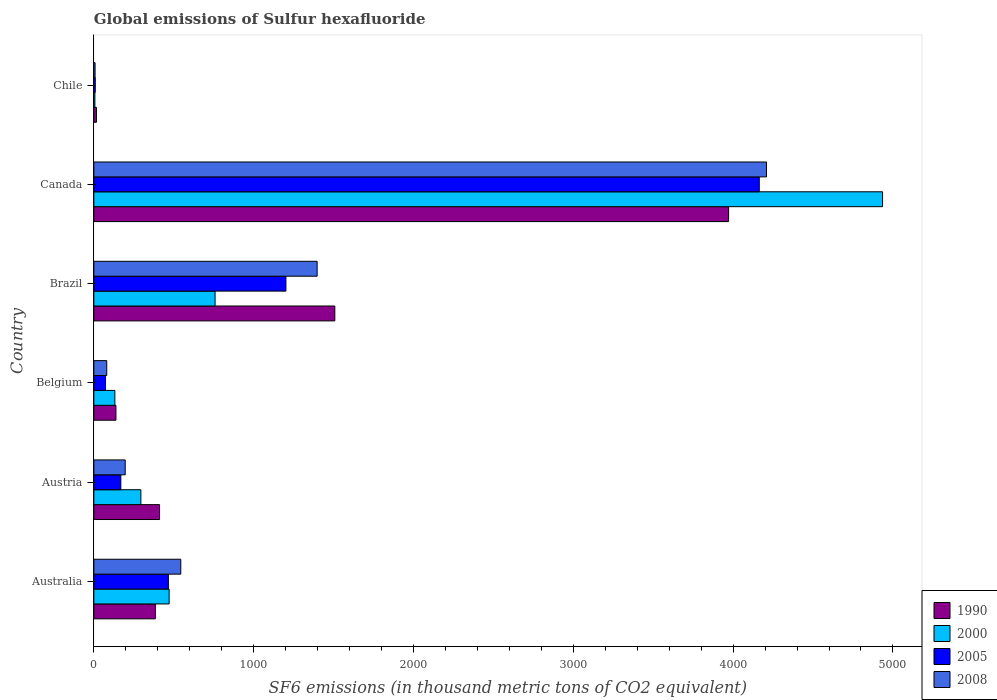How many groups of bars are there?
Your answer should be compact. 6. How many bars are there on the 1st tick from the top?
Your answer should be very brief. 4. How many bars are there on the 2nd tick from the bottom?
Provide a succinct answer. 4. What is the label of the 4th group of bars from the top?
Your answer should be compact. Belgium. In how many cases, is the number of bars for a given country not equal to the number of legend labels?
Offer a terse response. 0. What is the global emissions of Sulfur hexafluoride in 1990 in Brazil?
Your response must be concise. 1507.9. Across all countries, what is the maximum global emissions of Sulfur hexafluoride in 2005?
Your response must be concise. 4163.8. Across all countries, what is the minimum global emissions of Sulfur hexafluoride in 2000?
Your answer should be very brief. 6.7. In which country was the global emissions of Sulfur hexafluoride in 1990 maximum?
Your response must be concise. Canada. What is the total global emissions of Sulfur hexafluoride in 2005 in the graph?
Make the answer very short. 6083.3. What is the difference between the global emissions of Sulfur hexafluoride in 2005 in Australia and that in Austria?
Provide a short and direct response. 297.6. What is the difference between the global emissions of Sulfur hexafluoride in 2005 in Belgium and the global emissions of Sulfur hexafluoride in 1990 in Canada?
Your answer should be compact. -3898.9. What is the average global emissions of Sulfur hexafluoride in 2005 per country?
Offer a terse response. 1013.88. What is the ratio of the global emissions of Sulfur hexafluoride in 2008 in Australia to that in Chile?
Provide a short and direct response. 68.87. What is the difference between the highest and the second highest global emissions of Sulfur hexafluoride in 2005?
Make the answer very short. 2961.8. What is the difference between the highest and the lowest global emissions of Sulfur hexafluoride in 2005?
Your answer should be very brief. 4154.8. In how many countries, is the global emissions of Sulfur hexafluoride in 2000 greater than the average global emissions of Sulfur hexafluoride in 2000 taken over all countries?
Provide a succinct answer. 1. Is it the case that in every country, the sum of the global emissions of Sulfur hexafluoride in 2008 and global emissions of Sulfur hexafluoride in 2000 is greater than the sum of global emissions of Sulfur hexafluoride in 2005 and global emissions of Sulfur hexafluoride in 1990?
Provide a short and direct response. No. Is it the case that in every country, the sum of the global emissions of Sulfur hexafluoride in 2000 and global emissions of Sulfur hexafluoride in 2005 is greater than the global emissions of Sulfur hexafluoride in 2008?
Provide a succinct answer. Yes. How many bars are there?
Provide a short and direct response. 24. Are all the bars in the graph horizontal?
Make the answer very short. Yes. How many countries are there in the graph?
Make the answer very short. 6. Are the values on the major ticks of X-axis written in scientific E-notation?
Give a very brief answer. No. Does the graph contain grids?
Offer a terse response. No. How many legend labels are there?
Provide a short and direct response. 4. What is the title of the graph?
Ensure brevity in your answer.  Global emissions of Sulfur hexafluoride. Does "1960" appear as one of the legend labels in the graph?
Ensure brevity in your answer.  No. What is the label or title of the X-axis?
Your answer should be compact. SF6 emissions (in thousand metric tons of CO2 equivalent). What is the label or title of the Y-axis?
Give a very brief answer. Country. What is the SF6 emissions (in thousand metric tons of CO2 equivalent) in 1990 in Australia?
Offer a very short reply. 385.1. What is the SF6 emissions (in thousand metric tons of CO2 equivalent) of 2000 in Australia?
Make the answer very short. 471.2. What is the SF6 emissions (in thousand metric tons of CO2 equivalent) in 2005 in Australia?
Your answer should be compact. 466.6. What is the SF6 emissions (in thousand metric tons of CO2 equivalent) of 2008 in Australia?
Keep it short and to the point. 544.1. What is the SF6 emissions (in thousand metric tons of CO2 equivalent) in 1990 in Austria?
Provide a succinct answer. 411.2. What is the SF6 emissions (in thousand metric tons of CO2 equivalent) in 2000 in Austria?
Your response must be concise. 294.4. What is the SF6 emissions (in thousand metric tons of CO2 equivalent) in 2005 in Austria?
Your response must be concise. 169. What is the SF6 emissions (in thousand metric tons of CO2 equivalent) in 2008 in Austria?
Ensure brevity in your answer.  196.4. What is the SF6 emissions (in thousand metric tons of CO2 equivalent) of 1990 in Belgium?
Your answer should be very brief. 138.5. What is the SF6 emissions (in thousand metric tons of CO2 equivalent) in 2000 in Belgium?
Keep it short and to the point. 131.7. What is the SF6 emissions (in thousand metric tons of CO2 equivalent) of 2005 in Belgium?
Offer a very short reply. 72.9. What is the SF6 emissions (in thousand metric tons of CO2 equivalent) in 2008 in Belgium?
Your answer should be very brief. 80.9. What is the SF6 emissions (in thousand metric tons of CO2 equivalent) of 1990 in Brazil?
Offer a terse response. 1507.9. What is the SF6 emissions (in thousand metric tons of CO2 equivalent) of 2000 in Brazil?
Your answer should be compact. 758.7. What is the SF6 emissions (in thousand metric tons of CO2 equivalent) of 2005 in Brazil?
Ensure brevity in your answer.  1202. What is the SF6 emissions (in thousand metric tons of CO2 equivalent) of 2008 in Brazil?
Ensure brevity in your answer.  1397.3. What is the SF6 emissions (in thousand metric tons of CO2 equivalent) in 1990 in Canada?
Offer a very short reply. 3971.8. What is the SF6 emissions (in thousand metric tons of CO2 equivalent) in 2000 in Canada?
Make the answer very short. 4935.1. What is the SF6 emissions (in thousand metric tons of CO2 equivalent) in 2005 in Canada?
Your answer should be very brief. 4163.8. What is the SF6 emissions (in thousand metric tons of CO2 equivalent) in 2008 in Canada?
Make the answer very short. 4208.8. What is the SF6 emissions (in thousand metric tons of CO2 equivalent) in 2005 in Chile?
Your response must be concise. 9. What is the SF6 emissions (in thousand metric tons of CO2 equivalent) of 2008 in Chile?
Keep it short and to the point. 7.9. Across all countries, what is the maximum SF6 emissions (in thousand metric tons of CO2 equivalent) of 1990?
Keep it short and to the point. 3971.8. Across all countries, what is the maximum SF6 emissions (in thousand metric tons of CO2 equivalent) of 2000?
Offer a terse response. 4935.1. Across all countries, what is the maximum SF6 emissions (in thousand metric tons of CO2 equivalent) in 2005?
Offer a very short reply. 4163.8. Across all countries, what is the maximum SF6 emissions (in thousand metric tons of CO2 equivalent) in 2008?
Keep it short and to the point. 4208.8. Across all countries, what is the minimum SF6 emissions (in thousand metric tons of CO2 equivalent) in 1990?
Provide a succinct answer. 16.5. Across all countries, what is the minimum SF6 emissions (in thousand metric tons of CO2 equivalent) of 2000?
Your answer should be very brief. 6.7. Across all countries, what is the minimum SF6 emissions (in thousand metric tons of CO2 equivalent) in 2005?
Your response must be concise. 9. What is the total SF6 emissions (in thousand metric tons of CO2 equivalent) in 1990 in the graph?
Ensure brevity in your answer.  6431. What is the total SF6 emissions (in thousand metric tons of CO2 equivalent) in 2000 in the graph?
Your answer should be compact. 6597.8. What is the total SF6 emissions (in thousand metric tons of CO2 equivalent) of 2005 in the graph?
Give a very brief answer. 6083.3. What is the total SF6 emissions (in thousand metric tons of CO2 equivalent) of 2008 in the graph?
Your answer should be compact. 6435.4. What is the difference between the SF6 emissions (in thousand metric tons of CO2 equivalent) in 1990 in Australia and that in Austria?
Make the answer very short. -26.1. What is the difference between the SF6 emissions (in thousand metric tons of CO2 equivalent) in 2000 in Australia and that in Austria?
Give a very brief answer. 176.8. What is the difference between the SF6 emissions (in thousand metric tons of CO2 equivalent) in 2005 in Australia and that in Austria?
Keep it short and to the point. 297.6. What is the difference between the SF6 emissions (in thousand metric tons of CO2 equivalent) of 2008 in Australia and that in Austria?
Keep it short and to the point. 347.7. What is the difference between the SF6 emissions (in thousand metric tons of CO2 equivalent) of 1990 in Australia and that in Belgium?
Give a very brief answer. 246.6. What is the difference between the SF6 emissions (in thousand metric tons of CO2 equivalent) of 2000 in Australia and that in Belgium?
Keep it short and to the point. 339.5. What is the difference between the SF6 emissions (in thousand metric tons of CO2 equivalent) of 2005 in Australia and that in Belgium?
Offer a terse response. 393.7. What is the difference between the SF6 emissions (in thousand metric tons of CO2 equivalent) of 2008 in Australia and that in Belgium?
Ensure brevity in your answer.  463.2. What is the difference between the SF6 emissions (in thousand metric tons of CO2 equivalent) in 1990 in Australia and that in Brazil?
Your answer should be very brief. -1122.8. What is the difference between the SF6 emissions (in thousand metric tons of CO2 equivalent) in 2000 in Australia and that in Brazil?
Give a very brief answer. -287.5. What is the difference between the SF6 emissions (in thousand metric tons of CO2 equivalent) in 2005 in Australia and that in Brazil?
Give a very brief answer. -735.4. What is the difference between the SF6 emissions (in thousand metric tons of CO2 equivalent) of 2008 in Australia and that in Brazil?
Give a very brief answer. -853.2. What is the difference between the SF6 emissions (in thousand metric tons of CO2 equivalent) in 1990 in Australia and that in Canada?
Your answer should be compact. -3586.7. What is the difference between the SF6 emissions (in thousand metric tons of CO2 equivalent) in 2000 in Australia and that in Canada?
Provide a short and direct response. -4463.9. What is the difference between the SF6 emissions (in thousand metric tons of CO2 equivalent) in 2005 in Australia and that in Canada?
Keep it short and to the point. -3697.2. What is the difference between the SF6 emissions (in thousand metric tons of CO2 equivalent) in 2008 in Australia and that in Canada?
Provide a short and direct response. -3664.7. What is the difference between the SF6 emissions (in thousand metric tons of CO2 equivalent) in 1990 in Australia and that in Chile?
Give a very brief answer. 368.6. What is the difference between the SF6 emissions (in thousand metric tons of CO2 equivalent) in 2000 in Australia and that in Chile?
Provide a succinct answer. 464.5. What is the difference between the SF6 emissions (in thousand metric tons of CO2 equivalent) in 2005 in Australia and that in Chile?
Offer a terse response. 457.6. What is the difference between the SF6 emissions (in thousand metric tons of CO2 equivalent) in 2008 in Australia and that in Chile?
Make the answer very short. 536.2. What is the difference between the SF6 emissions (in thousand metric tons of CO2 equivalent) of 1990 in Austria and that in Belgium?
Offer a very short reply. 272.7. What is the difference between the SF6 emissions (in thousand metric tons of CO2 equivalent) in 2000 in Austria and that in Belgium?
Give a very brief answer. 162.7. What is the difference between the SF6 emissions (in thousand metric tons of CO2 equivalent) of 2005 in Austria and that in Belgium?
Your answer should be compact. 96.1. What is the difference between the SF6 emissions (in thousand metric tons of CO2 equivalent) in 2008 in Austria and that in Belgium?
Keep it short and to the point. 115.5. What is the difference between the SF6 emissions (in thousand metric tons of CO2 equivalent) in 1990 in Austria and that in Brazil?
Make the answer very short. -1096.7. What is the difference between the SF6 emissions (in thousand metric tons of CO2 equivalent) in 2000 in Austria and that in Brazil?
Provide a short and direct response. -464.3. What is the difference between the SF6 emissions (in thousand metric tons of CO2 equivalent) of 2005 in Austria and that in Brazil?
Provide a short and direct response. -1033. What is the difference between the SF6 emissions (in thousand metric tons of CO2 equivalent) of 2008 in Austria and that in Brazil?
Offer a terse response. -1200.9. What is the difference between the SF6 emissions (in thousand metric tons of CO2 equivalent) in 1990 in Austria and that in Canada?
Keep it short and to the point. -3560.6. What is the difference between the SF6 emissions (in thousand metric tons of CO2 equivalent) of 2000 in Austria and that in Canada?
Offer a terse response. -4640.7. What is the difference between the SF6 emissions (in thousand metric tons of CO2 equivalent) in 2005 in Austria and that in Canada?
Your response must be concise. -3994.8. What is the difference between the SF6 emissions (in thousand metric tons of CO2 equivalent) in 2008 in Austria and that in Canada?
Your response must be concise. -4012.4. What is the difference between the SF6 emissions (in thousand metric tons of CO2 equivalent) in 1990 in Austria and that in Chile?
Provide a succinct answer. 394.7. What is the difference between the SF6 emissions (in thousand metric tons of CO2 equivalent) of 2000 in Austria and that in Chile?
Your answer should be very brief. 287.7. What is the difference between the SF6 emissions (in thousand metric tons of CO2 equivalent) in 2005 in Austria and that in Chile?
Provide a short and direct response. 160. What is the difference between the SF6 emissions (in thousand metric tons of CO2 equivalent) of 2008 in Austria and that in Chile?
Your response must be concise. 188.5. What is the difference between the SF6 emissions (in thousand metric tons of CO2 equivalent) in 1990 in Belgium and that in Brazil?
Give a very brief answer. -1369.4. What is the difference between the SF6 emissions (in thousand metric tons of CO2 equivalent) of 2000 in Belgium and that in Brazil?
Ensure brevity in your answer.  -627. What is the difference between the SF6 emissions (in thousand metric tons of CO2 equivalent) of 2005 in Belgium and that in Brazil?
Keep it short and to the point. -1129.1. What is the difference between the SF6 emissions (in thousand metric tons of CO2 equivalent) of 2008 in Belgium and that in Brazil?
Give a very brief answer. -1316.4. What is the difference between the SF6 emissions (in thousand metric tons of CO2 equivalent) of 1990 in Belgium and that in Canada?
Provide a succinct answer. -3833.3. What is the difference between the SF6 emissions (in thousand metric tons of CO2 equivalent) of 2000 in Belgium and that in Canada?
Offer a very short reply. -4803.4. What is the difference between the SF6 emissions (in thousand metric tons of CO2 equivalent) of 2005 in Belgium and that in Canada?
Your response must be concise. -4090.9. What is the difference between the SF6 emissions (in thousand metric tons of CO2 equivalent) of 2008 in Belgium and that in Canada?
Provide a short and direct response. -4127.9. What is the difference between the SF6 emissions (in thousand metric tons of CO2 equivalent) of 1990 in Belgium and that in Chile?
Offer a very short reply. 122. What is the difference between the SF6 emissions (in thousand metric tons of CO2 equivalent) of 2000 in Belgium and that in Chile?
Ensure brevity in your answer.  125. What is the difference between the SF6 emissions (in thousand metric tons of CO2 equivalent) in 2005 in Belgium and that in Chile?
Provide a succinct answer. 63.9. What is the difference between the SF6 emissions (in thousand metric tons of CO2 equivalent) of 2008 in Belgium and that in Chile?
Your response must be concise. 73. What is the difference between the SF6 emissions (in thousand metric tons of CO2 equivalent) in 1990 in Brazil and that in Canada?
Your response must be concise. -2463.9. What is the difference between the SF6 emissions (in thousand metric tons of CO2 equivalent) in 2000 in Brazil and that in Canada?
Offer a very short reply. -4176.4. What is the difference between the SF6 emissions (in thousand metric tons of CO2 equivalent) of 2005 in Brazil and that in Canada?
Your response must be concise. -2961.8. What is the difference between the SF6 emissions (in thousand metric tons of CO2 equivalent) in 2008 in Brazil and that in Canada?
Your response must be concise. -2811.5. What is the difference between the SF6 emissions (in thousand metric tons of CO2 equivalent) of 1990 in Brazil and that in Chile?
Your answer should be compact. 1491.4. What is the difference between the SF6 emissions (in thousand metric tons of CO2 equivalent) of 2000 in Brazil and that in Chile?
Your answer should be very brief. 752. What is the difference between the SF6 emissions (in thousand metric tons of CO2 equivalent) of 2005 in Brazil and that in Chile?
Your answer should be compact. 1193. What is the difference between the SF6 emissions (in thousand metric tons of CO2 equivalent) of 2008 in Brazil and that in Chile?
Ensure brevity in your answer.  1389.4. What is the difference between the SF6 emissions (in thousand metric tons of CO2 equivalent) of 1990 in Canada and that in Chile?
Ensure brevity in your answer.  3955.3. What is the difference between the SF6 emissions (in thousand metric tons of CO2 equivalent) of 2000 in Canada and that in Chile?
Offer a very short reply. 4928.4. What is the difference between the SF6 emissions (in thousand metric tons of CO2 equivalent) of 2005 in Canada and that in Chile?
Your answer should be very brief. 4154.8. What is the difference between the SF6 emissions (in thousand metric tons of CO2 equivalent) in 2008 in Canada and that in Chile?
Your answer should be very brief. 4200.9. What is the difference between the SF6 emissions (in thousand metric tons of CO2 equivalent) of 1990 in Australia and the SF6 emissions (in thousand metric tons of CO2 equivalent) of 2000 in Austria?
Your answer should be compact. 90.7. What is the difference between the SF6 emissions (in thousand metric tons of CO2 equivalent) of 1990 in Australia and the SF6 emissions (in thousand metric tons of CO2 equivalent) of 2005 in Austria?
Offer a terse response. 216.1. What is the difference between the SF6 emissions (in thousand metric tons of CO2 equivalent) in 1990 in Australia and the SF6 emissions (in thousand metric tons of CO2 equivalent) in 2008 in Austria?
Ensure brevity in your answer.  188.7. What is the difference between the SF6 emissions (in thousand metric tons of CO2 equivalent) of 2000 in Australia and the SF6 emissions (in thousand metric tons of CO2 equivalent) of 2005 in Austria?
Ensure brevity in your answer.  302.2. What is the difference between the SF6 emissions (in thousand metric tons of CO2 equivalent) in 2000 in Australia and the SF6 emissions (in thousand metric tons of CO2 equivalent) in 2008 in Austria?
Give a very brief answer. 274.8. What is the difference between the SF6 emissions (in thousand metric tons of CO2 equivalent) in 2005 in Australia and the SF6 emissions (in thousand metric tons of CO2 equivalent) in 2008 in Austria?
Ensure brevity in your answer.  270.2. What is the difference between the SF6 emissions (in thousand metric tons of CO2 equivalent) of 1990 in Australia and the SF6 emissions (in thousand metric tons of CO2 equivalent) of 2000 in Belgium?
Your answer should be compact. 253.4. What is the difference between the SF6 emissions (in thousand metric tons of CO2 equivalent) of 1990 in Australia and the SF6 emissions (in thousand metric tons of CO2 equivalent) of 2005 in Belgium?
Offer a terse response. 312.2. What is the difference between the SF6 emissions (in thousand metric tons of CO2 equivalent) in 1990 in Australia and the SF6 emissions (in thousand metric tons of CO2 equivalent) in 2008 in Belgium?
Keep it short and to the point. 304.2. What is the difference between the SF6 emissions (in thousand metric tons of CO2 equivalent) of 2000 in Australia and the SF6 emissions (in thousand metric tons of CO2 equivalent) of 2005 in Belgium?
Provide a succinct answer. 398.3. What is the difference between the SF6 emissions (in thousand metric tons of CO2 equivalent) in 2000 in Australia and the SF6 emissions (in thousand metric tons of CO2 equivalent) in 2008 in Belgium?
Provide a short and direct response. 390.3. What is the difference between the SF6 emissions (in thousand metric tons of CO2 equivalent) in 2005 in Australia and the SF6 emissions (in thousand metric tons of CO2 equivalent) in 2008 in Belgium?
Make the answer very short. 385.7. What is the difference between the SF6 emissions (in thousand metric tons of CO2 equivalent) in 1990 in Australia and the SF6 emissions (in thousand metric tons of CO2 equivalent) in 2000 in Brazil?
Your answer should be compact. -373.6. What is the difference between the SF6 emissions (in thousand metric tons of CO2 equivalent) in 1990 in Australia and the SF6 emissions (in thousand metric tons of CO2 equivalent) in 2005 in Brazil?
Your answer should be compact. -816.9. What is the difference between the SF6 emissions (in thousand metric tons of CO2 equivalent) in 1990 in Australia and the SF6 emissions (in thousand metric tons of CO2 equivalent) in 2008 in Brazil?
Make the answer very short. -1012.2. What is the difference between the SF6 emissions (in thousand metric tons of CO2 equivalent) in 2000 in Australia and the SF6 emissions (in thousand metric tons of CO2 equivalent) in 2005 in Brazil?
Your response must be concise. -730.8. What is the difference between the SF6 emissions (in thousand metric tons of CO2 equivalent) of 2000 in Australia and the SF6 emissions (in thousand metric tons of CO2 equivalent) of 2008 in Brazil?
Offer a terse response. -926.1. What is the difference between the SF6 emissions (in thousand metric tons of CO2 equivalent) in 2005 in Australia and the SF6 emissions (in thousand metric tons of CO2 equivalent) in 2008 in Brazil?
Provide a succinct answer. -930.7. What is the difference between the SF6 emissions (in thousand metric tons of CO2 equivalent) in 1990 in Australia and the SF6 emissions (in thousand metric tons of CO2 equivalent) in 2000 in Canada?
Your response must be concise. -4550. What is the difference between the SF6 emissions (in thousand metric tons of CO2 equivalent) of 1990 in Australia and the SF6 emissions (in thousand metric tons of CO2 equivalent) of 2005 in Canada?
Offer a terse response. -3778.7. What is the difference between the SF6 emissions (in thousand metric tons of CO2 equivalent) of 1990 in Australia and the SF6 emissions (in thousand metric tons of CO2 equivalent) of 2008 in Canada?
Your answer should be very brief. -3823.7. What is the difference between the SF6 emissions (in thousand metric tons of CO2 equivalent) of 2000 in Australia and the SF6 emissions (in thousand metric tons of CO2 equivalent) of 2005 in Canada?
Provide a short and direct response. -3692.6. What is the difference between the SF6 emissions (in thousand metric tons of CO2 equivalent) of 2000 in Australia and the SF6 emissions (in thousand metric tons of CO2 equivalent) of 2008 in Canada?
Keep it short and to the point. -3737.6. What is the difference between the SF6 emissions (in thousand metric tons of CO2 equivalent) in 2005 in Australia and the SF6 emissions (in thousand metric tons of CO2 equivalent) in 2008 in Canada?
Your response must be concise. -3742.2. What is the difference between the SF6 emissions (in thousand metric tons of CO2 equivalent) in 1990 in Australia and the SF6 emissions (in thousand metric tons of CO2 equivalent) in 2000 in Chile?
Give a very brief answer. 378.4. What is the difference between the SF6 emissions (in thousand metric tons of CO2 equivalent) in 1990 in Australia and the SF6 emissions (in thousand metric tons of CO2 equivalent) in 2005 in Chile?
Offer a terse response. 376.1. What is the difference between the SF6 emissions (in thousand metric tons of CO2 equivalent) of 1990 in Australia and the SF6 emissions (in thousand metric tons of CO2 equivalent) of 2008 in Chile?
Keep it short and to the point. 377.2. What is the difference between the SF6 emissions (in thousand metric tons of CO2 equivalent) of 2000 in Australia and the SF6 emissions (in thousand metric tons of CO2 equivalent) of 2005 in Chile?
Make the answer very short. 462.2. What is the difference between the SF6 emissions (in thousand metric tons of CO2 equivalent) of 2000 in Australia and the SF6 emissions (in thousand metric tons of CO2 equivalent) of 2008 in Chile?
Your answer should be very brief. 463.3. What is the difference between the SF6 emissions (in thousand metric tons of CO2 equivalent) of 2005 in Australia and the SF6 emissions (in thousand metric tons of CO2 equivalent) of 2008 in Chile?
Keep it short and to the point. 458.7. What is the difference between the SF6 emissions (in thousand metric tons of CO2 equivalent) of 1990 in Austria and the SF6 emissions (in thousand metric tons of CO2 equivalent) of 2000 in Belgium?
Your answer should be very brief. 279.5. What is the difference between the SF6 emissions (in thousand metric tons of CO2 equivalent) of 1990 in Austria and the SF6 emissions (in thousand metric tons of CO2 equivalent) of 2005 in Belgium?
Give a very brief answer. 338.3. What is the difference between the SF6 emissions (in thousand metric tons of CO2 equivalent) in 1990 in Austria and the SF6 emissions (in thousand metric tons of CO2 equivalent) in 2008 in Belgium?
Provide a succinct answer. 330.3. What is the difference between the SF6 emissions (in thousand metric tons of CO2 equivalent) of 2000 in Austria and the SF6 emissions (in thousand metric tons of CO2 equivalent) of 2005 in Belgium?
Offer a very short reply. 221.5. What is the difference between the SF6 emissions (in thousand metric tons of CO2 equivalent) in 2000 in Austria and the SF6 emissions (in thousand metric tons of CO2 equivalent) in 2008 in Belgium?
Make the answer very short. 213.5. What is the difference between the SF6 emissions (in thousand metric tons of CO2 equivalent) in 2005 in Austria and the SF6 emissions (in thousand metric tons of CO2 equivalent) in 2008 in Belgium?
Offer a very short reply. 88.1. What is the difference between the SF6 emissions (in thousand metric tons of CO2 equivalent) in 1990 in Austria and the SF6 emissions (in thousand metric tons of CO2 equivalent) in 2000 in Brazil?
Your answer should be very brief. -347.5. What is the difference between the SF6 emissions (in thousand metric tons of CO2 equivalent) of 1990 in Austria and the SF6 emissions (in thousand metric tons of CO2 equivalent) of 2005 in Brazil?
Offer a terse response. -790.8. What is the difference between the SF6 emissions (in thousand metric tons of CO2 equivalent) in 1990 in Austria and the SF6 emissions (in thousand metric tons of CO2 equivalent) in 2008 in Brazil?
Your answer should be very brief. -986.1. What is the difference between the SF6 emissions (in thousand metric tons of CO2 equivalent) of 2000 in Austria and the SF6 emissions (in thousand metric tons of CO2 equivalent) of 2005 in Brazil?
Offer a terse response. -907.6. What is the difference between the SF6 emissions (in thousand metric tons of CO2 equivalent) of 2000 in Austria and the SF6 emissions (in thousand metric tons of CO2 equivalent) of 2008 in Brazil?
Offer a very short reply. -1102.9. What is the difference between the SF6 emissions (in thousand metric tons of CO2 equivalent) in 2005 in Austria and the SF6 emissions (in thousand metric tons of CO2 equivalent) in 2008 in Brazil?
Provide a short and direct response. -1228.3. What is the difference between the SF6 emissions (in thousand metric tons of CO2 equivalent) in 1990 in Austria and the SF6 emissions (in thousand metric tons of CO2 equivalent) in 2000 in Canada?
Provide a short and direct response. -4523.9. What is the difference between the SF6 emissions (in thousand metric tons of CO2 equivalent) of 1990 in Austria and the SF6 emissions (in thousand metric tons of CO2 equivalent) of 2005 in Canada?
Offer a very short reply. -3752.6. What is the difference between the SF6 emissions (in thousand metric tons of CO2 equivalent) of 1990 in Austria and the SF6 emissions (in thousand metric tons of CO2 equivalent) of 2008 in Canada?
Give a very brief answer. -3797.6. What is the difference between the SF6 emissions (in thousand metric tons of CO2 equivalent) of 2000 in Austria and the SF6 emissions (in thousand metric tons of CO2 equivalent) of 2005 in Canada?
Your answer should be compact. -3869.4. What is the difference between the SF6 emissions (in thousand metric tons of CO2 equivalent) in 2000 in Austria and the SF6 emissions (in thousand metric tons of CO2 equivalent) in 2008 in Canada?
Make the answer very short. -3914.4. What is the difference between the SF6 emissions (in thousand metric tons of CO2 equivalent) of 2005 in Austria and the SF6 emissions (in thousand metric tons of CO2 equivalent) of 2008 in Canada?
Keep it short and to the point. -4039.8. What is the difference between the SF6 emissions (in thousand metric tons of CO2 equivalent) in 1990 in Austria and the SF6 emissions (in thousand metric tons of CO2 equivalent) in 2000 in Chile?
Offer a very short reply. 404.5. What is the difference between the SF6 emissions (in thousand metric tons of CO2 equivalent) of 1990 in Austria and the SF6 emissions (in thousand metric tons of CO2 equivalent) of 2005 in Chile?
Offer a terse response. 402.2. What is the difference between the SF6 emissions (in thousand metric tons of CO2 equivalent) in 1990 in Austria and the SF6 emissions (in thousand metric tons of CO2 equivalent) in 2008 in Chile?
Offer a very short reply. 403.3. What is the difference between the SF6 emissions (in thousand metric tons of CO2 equivalent) in 2000 in Austria and the SF6 emissions (in thousand metric tons of CO2 equivalent) in 2005 in Chile?
Your answer should be very brief. 285.4. What is the difference between the SF6 emissions (in thousand metric tons of CO2 equivalent) in 2000 in Austria and the SF6 emissions (in thousand metric tons of CO2 equivalent) in 2008 in Chile?
Your response must be concise. 286.5. What is the difference between the SF6 emissions (in thousand metric tons of CO2 equivalent) of 2005 in Austria and the SF6 emissions (in thousand metric tons of CO2 equivalent) of 2008 in Chile?
Give a very brief answer. 161.1. What is the difference between the SF6 emissions (in thousand metric tons of CO2 equivalent) of 1990 in Belgium and the SF6 emissions (in thousand metric tons of CO2 equivalent) of 2000 in Brazil?
Your answer should be very brief. -620.2. What is the difference between the SF6 emissions (in thousand metric tons of CO2 equivalent) in 1990 in Belgium and the SF6 emissions (in thousand metric tons of CO2 equivalent) in 2005 in Brazil?
Offer a terse response. -1063.5. What is the difference between the SF6 emissions (in thousand metric tons of CO2 equivalent) of 1990 in Belgium and the SF6 emissions (in thousand metric tons of CO2 equivalent) of 2008 in Brazil?
Ensure brevity in your answer.  -1258.8. What is the difference between the SF6 emissions (in thousand metric tons of CO2 equivalent) of 2000 in Belgium and the SF6 emissions (in thousand metric tons of CO2 equivalent) of 2005 in Brazil?
Ensure brevity in your answer.  -1070.3. What is the difference between the SF6 emissions (in thousand metric tons of CO2 equivalent) of 2000 in Belgium and the SF6 emissions (in thousand metric tons of CO2 equivalent) of 2008 in Brazil?
Keep it short and to the point. -1265.6. What is the difference between the SF6 emissions (in thousand metric tons of CO2 equivalent) of 2005 in Belgium and the SF6 emissions (in thousand metric tons of CO2 equivalent) of 2008 in Brazil?
Give a very brief answer. -1324.4. What is the difference between the SF6 emissions (in thousand metric tons of CO2 equivalent) of 1990 in Belgium and the SF6 emissions (in thousand metric tons of CO2 equivalent) of 2000 in Canada?
Provide a short and direct response. -4796.6. What is the difference between the SF6 emissions (in thousand metric tons of CO2 equivalent) in 1990 in Belgium and the SF6 emissions (in thousand metric tons of CO2 equivalent) in 2005 in Canada?
Ensure brevity in your answer.  -4025.3. What is the difference between the SF6 emissions (in thousand metric tons of CO2 equivalent) in 1990 in Belgium and the SF6 emissions (in thousand metric tons of CO2 equivalent) in 2008 in Canada?
Offer a terse response. -4070.3. What is the difference between the SF6 emissions (in thousand metric tons of CO2 equivalent) in 2000 in Belgium and the SF6 emissions (in thousand metric tons of CO2 equivalent) in 2005 in Canada?
Provide a short and direct response. -4032.1. What is the difference between the SF6 emissions (in thousand metric tons of CO2 equivalent) of 2000 in Belgium and the SF6 emissions (in thousand metric tons of CO2 equivalent) of 2008 in Canada?
Offer a terse response. -4077.1. What is the difference between the SF6 emissions (in thousand metric tons of CO2 equivalent) in 2005 in Belgium and the SF6 emissions (in thousand metric tons of CO2 equivalent) in 2008 in Canada?
Give a very brief answer. -4135.9. What is the difference between the SF6 emissions (in thousand metric tons of CO2 equivalent) of 1990 in Belgium and the SF6 emissions (in thousand metric tons of CO2 equivalent) of 2000 in Chile?
Offer a very short reply. 131.8. What is the difference between the SF6 emissions (in thousand metric tons of CO2 equivalent) in 1990 in Belgium and the SF6 emissions (in thousand metric tons of CO2 equivalent) in 2005 in Chile?
Your answer should be compact. 129.5. What is the difference between the SF6 emissions (in thousand metric tons of CO2 equivalent) in 1990 in Belgium and the SF6 emissions (in thousand metric tons of CO2 equivalent) in 2008 in Chile?
Your answer should be compact. 130.6. What is the difference between the SF6 emissions (in thousand metric tons of CO2 equivalent) in 2000 in Belgium and the SF6 emissions (in thousand metric tons of CO2 equivalent) in 2005 in Chile?
Provide a succinct answer. 122.7. What is the difference between the SF6 emissions (in thousand metric tons of CO2 equivalent) of 2000 in Belgium and the SF6 emissions (in thousand metric tons of CO2 equivalent) of 2008 in Chile?
Your answer should be very brief. 123.8. What is the difference between the SF6 emissions (in thousand metric tons of CO2 equivalent) of 2005 in Belgium and the SF6 emissions (in thousand metric tons of CO2 equivalent) of 2008 in Chile?
Your answer should be compact. 65. What is the difference between the SF6 emissions (in thousand metric tons of CO2 equivalent) in 1990 in Brazil and the SF6 emissions (in thousand metric tons of CO2 equivalent) in 2000 in Canada?
Ensure brevity in your answer.  -3427.2. What is the difference between the SF6 emissions (in thousand metric tons of CO2 equivalent) of 1990 in Brazil and the SF6 emissions (in thousand metric tons of CO2 equivalent) of 2005 in Canada?
Make the answer very short. -2655.9. What is the difference between the SF6 emissions (in thousand metric tons of CO2 equivalent) of 1990 in Brazil and the SF6 emissions (in thousand metric tons of CO2 equivalent) of 2008 in Canada?
Make the answer very short. -2700.9. What is the difference between the SF6 emissions (in thousand metric tons of CO2 equivalent) in 2000 in Brazil and the SF6 emissions (in thousand metric tons of CO2 equivalent) in 2005 in Canada?
Your answer should be very brief. -3405.1. What is the difference between the SF6 emissions (in thousand metric tons of CO2 equivalent) in 2000 in Brazil and the SF6 emissions (in thousand metric tons of CO2 equivalent) in 2008 in Canada?
Your answer should be very brief. -3450.1. What is the difference between the SF6 emissions (in thousand metric tons of CO2 equivalent) of 2005 in Brazil and the SF6 emissions (in thousand metric tons of CO2 equivalent) of 2008 in Canada?
Provide a succinct answer. -3006.8. What is the difference between the SF6 emissions (in thousand metric tons of CO2 equivalent) of 1990 in Brazil and the SF6 emissions (in thousand metric tons of CO2 equivalent) of 2000 in Chile?
Provide a succinct answer. 1501.2. What is the difference between the SF6 emissions (in thousand metric tons of CO2 equivalent) of 1990 in Brazil and the SF6 emissions (in thousand metric tons of CO2 equivalent) of 2005 in Chile?
Your answer should be very brief. 1498.9. What is the difference between the SF6 emissions (in thousand metric tons of CO2 equivalent) of 1990 in Brazil and the SF6 emissions (in thousand metric tons of CO2 equivalent) of 2008 in Chile?
Your answer should be compact. 1500. What is the difference between the SF6 emissions (in thousand metric tons of CO2 equivalent) in 2000 in Brazil and the SF6 emissions (in thousand metric tons of CO2 equivalent) in 2005 in Chile?
Make the answer very short. 749.7. What is the difference between the SF6 emissions (in thousand metric tons of CO2 equivalent) of 2000 in Brazil and the SF6 emissions (in thousand metric tons of CO2 equivalent) of 2008 in Chile?
Your answer should be very brief. 750.8. What is the difference between the SF6 emissions (in thousand metric tons of CO2 equivalent) of 2005 in Brazil and the SF6 emissions (in thousand metric tons of CO2 equivalent) of 2008 in Chile?
Ensure brevity in your answer.  1194.1. What is the difference between the SF6 emissions (in thousand metric tons of CO2 equivalent) of 1990 in Canada and the SF6 emissions (in thousand metric tons of CO2 equivalent) of 2000 in Chile?
Keep it short and to the point. 3965.1. What is the difference between the SF6 emissions (in thousand metric tons of CO2 equivalent) of 1990 in Canada and the SF6 emissions (in thousand metric tons of CO2 equivalent) of 2005 in Chile?
Your response must be concise. 3962.8. What is the difference between the SF6 emissions (in thousand metric tons of CO2 equivalent) of 1990 in Canada and the SF6 emissions (in thousand metric tons of CO2 equivalent) of 2008 in Chile?
Make the answer very short. 3963.9. What is the difference between the SF6 emissions (in thousand metric tons of CO2 equivalent) of 2000 in Canada and the SF6 emissions (in thousand metric tons of CO2 equivalent) of 2005 in Chile?
Provide a short and direct response. 4926.1. What is the difference between the SF6 emissions (in thousand metric tons of CO2 equivalent) in 2000 in Canada and the SF6 emissions (in thousand metric tons of CO2 equivalent) in 2008 in Chile?
Provide a succinct answer. 4927.2. What is the difference between the SF6 emissions (in thousand metric tons of CO2 equivalent) of 2005 in Canada and the SF6 emissions (in thousand metric tons of CO2 equivalent) of 2008 in Chile?
Ensure brevity in your answer.  4155.9. What is the average SF6 emissions (in thousand metric tons of CO2 equivalent) of 1990 per country?
Your response must be concise. 1071.83. What is the average SF6 emissions (in thousand metric tons of CO2 equivalent) in 2000 per country?
Your answer should be compact. 1099.63. What is the average SF6 emissions (in thousand metric tons of CO2 equivalent) of 2005 per country?
Your answer should be compact. 1013.88. What is the average SF6 emissions (in thousand metric tons of CO2 equivalent) in 2008 per country?
Make the answer very short. 1072.57. What is the difference between the SF6 emissions (in thousand metric tons of CO2 equivalent) in 1990 and SF6 emissions (in thousand metric tons of CO2 equivalent) in 2000 in Australia?
Offer a terse response. -86.1. What is the difference between the SF6 emissions (in thousand metric tons of CO2 equivalent) of 1990 and SF6 emissions (in thousand metric tons of CO2 equivalent) of 2005 in Australia?
Your answer should be compact. -81.5. What is the difference between the SF6 emissions (in thousand metric tons of CO2 equivalent) in 1990 and SF6 emissions (in thousand metric tons of CO2 equivalent) in 2008 in Australia?
Provide a succinct answer. -159. What is the difference between the SF6 emissions (in thousand metric tons of CO2 equivalent) in 2000 and SF6 emissions (in thousand metric tons of CO2 equivalent) in 2005 in Australia?
Make the answer very short. 4.6. What is the difference between the SF6 emissions (in thousand metric tons of CO2 equivalent) of 2000 and SF6 emissions (in thousand metric tons of CO2 equivalent) of 2008 in Australia?
Offer a terse response. -72.9. What is the difference between the SF6 emissions (in thousand metric tons of CO2 equivalent) in 2005 and SF6 emissions (in thousand metric tons of CO2 equivalent) in 2008 in Australia?
Ensure brevity in your answer.  -77.5. What is the difference between the SF6 emissions (in thousand metric tons of CO2 equivalent) in 1990 and SF6 emissions (in thousand metric tons of CO2 equivalent) in 2000 in Austria?
Ensure brevity in your answer.  116.8. What is the difference between the SF6 emissions (in thousand metric tons of CO2 equivalent) of 1990 and SF6 emissions (in thousand metric tons of CO2 equivalent) of 2005 in Austria?
Keep it short and to the point. 242.2. What is the difference between the SF6 emissions (in thousand metric tons of CO2 equivalent) of 1990 and SF6 emissions (in thousand metric tons of CO2 equivalent) of 2008 in Austria?
Your answer should be very brief. 214.8. What is the difference between the SF6 emissions (in thousand metric tons of CO2 equivalent) in 2000 and SF6 emissions (in thousand metric tons of CO2 equivalent) in 2005 in Austria?
Make the answer very short. 125.4. What is the difference between the SF6 emissions (in thousand metric tons of CO2 equivalent) in 2005 and SF6 emissions (in thousand metric tons of CO2 equivalent) in 2008 in Austria?
Provide a succinct answer. -27.4. What is the difference between the SF6 emissions (in thousand metric tons of CO2 equivalent) in 1990 and SF6 emissions (in thousand metric tons of CO2 equivalent) in 2000 in Belgium?
Ensure brevity in your answer.  6.8. What is the difference between the SF6 emissions (in thousand metric tons of CO2 equivalent) in 1990 and SF6 emissions (in thousand metric tons of CO2 equivalent) in 2005 in Belgium?
Provide a short and direct response. 65.6. What is the difference between the SF6 emissions (in thousand metric tons of CO2 equivalent) in 1990 and SF6 emissions (in thousand metric tons of CO2 equivalent) in 2008 in Belgium?
Provide a short and direct response. 57.6. What is the difference between the SF6 emissions (in thousand metric tons of CO2 equivalent) in 2000 and SF6 emissions (in thousand metric tons of CO2 equivalent) in 2005 in Belgium?
Your answer should be very brief. 58.8. What is the difference between the SF6 emissions (in thousand metric tons of CO2 equivalent) of 2000 and SF6 emissions (in thousand metric tons of CO2 equivalent) of 2008 in Belgium?
Offer a very short reply. 50.8. What is the difference between the SF6 emissions (in thousand metric tons of CO2 equivalent) in 2005 and SF6 emissions (in thousand metric tons of CO2 equivalent) in 2008 in Belgium?
Give a very brief answer. -8. What is the difference between the SF6 emissions (in thousand metric tons of CO2 equivalent) in 1990 and SF6 emissions (in thousand metric tons of CO2 equivalent) in 2000 in Brazil?
Offer a terse response. 749.2. What is the difference between the SF6 emissions (in thousand metric tons of CO2 equivalent) of 1990 and SF6 emissions (in thousand metric tons of CO2 equivalent) of 2005 in Brazil?
Your answer should be compact. 305.9. What is the difference between the SF6 emissions (in thousand metric tons of CO2 equivalent) of 1990 and SF6 emissions (in thousand metric tons of CO2 equivalent) of 2008 in Brazil?
Offer a very short reply. 110.6. What is the difference between the SF6 emissions (in thousand metric tons of CO2 equivalent) of 2000 and SF6 emissions (in thousand metric tons of CO2 equivalent) of 2005 in Brazil?
Offer a terse response. -443.3. What is the difference between the SF6 emissions (in thousand metric tons of CO2 equivalent) in 2000 and SF6 emissions (in thousand metric tons of CO2 equivalent) in 2008 in Brazil?
Your response must be concise. -638.6. What is the difference between the SF6 emissions (in thousand metric tons of CO2 equivalent) in 2005 and SF6 emissions (in thousand metric tons of CO2 equivalent) in 2008 in Brazil?
Offer a very short reply. -195.3. What is the difference between the SF6 emissions (in thousand metric tons of CO2 equivalent) in 1990 and SF6 emissions (in thousand metric tons of CO2 equivalent) in 2000 in Canada?
Your response must be concise. -963.3. What is the difference between the SF6 emissions (in thousand metric tons of CO2 equivalent) in 1990 and SF6 emissions (in thousand metric tons of CO2 equivalent) in 2005 in Canada?
Offer a terse response. -192. What is the difference between the SF6 emissions (in thousand metric tons of CO2 equivalent) in 1990 and SF6 emissions (in thousand metric tons of CO2 equivalent) in 2008 in Canada?
Provide a short and direct response. -237. What is the difference between the SF6 emissions (in thousand metric tons of CO2 equivalent) in 2000 and SF6 emissions (in thousand metric tons of CO2 equivalent) in 2005 in Canada?
Offer a terse response. 771.3. What is the difference between the SF6 emissions (in thousand metric tons of CO2 equivalent) in 2000 and SF6 emissions (in thousand metric tons of CO2 equivalent) in 2008 in Canada?
Offer a terse response. 726.3. What is the difference between the SF6 emissions (in thousand metric tons of CO2 equivalent) of 2005 and SF6 emissions (in thousand metric tons of CO2 equivalent) of 2008 in Canada?
Your answer should be compact. -45. What is the difference between the SF6 emissions (in thousand metric tons of CO2 equivalent) of 1990 and SF6 emissions (in thousand metric tons of CO2 equivalent) of 2000 in Chile?
Offer a terse response. 9.8. What is the difference between the SF6 emissions (in thousand metric tons of CO2 equivalent) in 1990 and SF6 emissions (in thousand metric tons of CO2 equivalent) in 2008 in Chile?
Your response must be concise. 8.6. What is the difference between the SF6 emissions (in thousand metric tons of CO2 equivalent) of 2005 and SF6 emissions (in thousand metric tons of CO2 equivalent) of 2008 in Chile?
Offer a terse response. 1.1. What is the ratio of the SF6 emissions (in thousand metric tons of CO2 equivalent) in 1990 in Australia to that in Austria?
Offer a very short reply. 0.94. What is the ratio of the SF6 emissions (in thousand metric tons of CO2 equivalent) in 2000 in Australia to that in Austria?
Ensure brevity in your answer.  1.6. What is the ratio of the SF6 emissions (in thousand metric tons of CO2 equivalent) in 2005 in Australia to that in Austria?
Make the answer very short. 2.76. What is the ratio of the SF6 emissions (in thousand metric tons of CO2 equivalent) in 2008 in Australia to that in Austria?
Your answer should be compact. 2.77. What is the ratio of the SF6 emissions (in thousand metric tons of CO2 equivalent) of 1990 in Australia to that in Belgium?
Make the answer very short. 2.78. What is the ratio of the SF6 emissions (in thousand metric tons of CO2 equivalent) in 2000 in Australia to that in Belgium?
Ensure brevity in your answer.  3.58. What is the ratio of the SF6 emissions (in thousand metric tons of CO2 equivalent) in 2005 in Australia to that in Belgium?
Give a very brief answer. 6.4. What is the ratio of the SF6 emissions (in thousand metric tons of CO2 equivalent) of 2008 in Australia to that in Belgium?
Your answer should be compact. 6.73. What is the ratio of the SF6 emissions (in thousand metric tons of CO2 equivalent) in 1990 in Australia to that in Brazil?
Your response must be concise. 0.26. What is the ratio of the SF6 emissions (in thousand metric tons of CO2 equivalent) of 2000 in Australia to that in Brazil?
Give a very brief answer. 0.62. What is the ratio of the SF6 emissions (in thousand metric tons of CO2 equivalent) of 2005 in Australia to that in Brazil?
Your answer should be very brief. 0.39. What is the ratio of the SF6 emissions (in thousand metric tons of CO2 equivalent) of 2008 in Australia to that in Brazil?
Ensure brevity in your answer.  0.39. What is the ratio of the SF6 emissions (in thousand metric tons of CO2 equivalent) in 1990 in Australia to that in Canada?
Offer a very short reply. 0.1. What is the ratio of the SF6 emissions (in thousand metric tons of CO2 equivalent) in 2000 in Australia to that in Canada?
Offer a very short reply. 0.1. What is the ratio of the SF6 emissions (in thousand metric tons of CO2 equivalent) in 2005 in Australia to that in Canada?
Ensure brevity in your answer.  0.11. What is the ratio of the SF6 emissions (in thousand metric tons of CO2 equivalent) in 2008 in Australia to that in Canada?
Offer a terse response. 0.13. What is the ratio of the SF6 emissions (in thousand metric tons of CO2 equivalent) in 1990 in Australia to that in Chile?
Make the answer very short. 23.34. What is the ratio of the SF6 emissions (in thousand metric tons of CO2 equivalent) of 2000 in Australia to that in Chile?
Make the answer very short. 70.33. What is the ratio of the SF6 emissions (in thousand metric tons of CO2 equivalent) of 2005 in Australia to that in Chile?
Ensure brevity in your answer.  51.84. What is the ratio of the SF6 emissions (in thousand metric tons of CO2 equivalent) in 2008 in Australia to that in Chile?
Ensure brevity in your answer.  68.87. What is the ratio of the SF6 emissions (in thousand metric tons of CO2 equivalent) of 1990 in Austria to that in Belgium?
Give a very brief answer. 2.97. What is the ratio of the SF6 emissions (in thousand metric tons of CO2 equivalent) in 2000 in Austria to that in Belgium?
Your answer should be compact. 2.24. What is the ratio of the SF6 emissions (in thousand metric tons of CO2 equivalent) of 2005 in Austria to that in Belgium?
Offer a terse response. 2.32. What is the ratio of the SF6 emissions (in thousand metric tons of CO2 equivalent) of 2008 in Austria to that in Belgium?
Offer a terse response. 2.43. What is the ratio of the SF6 emissions (in thousand metric tons of CO2 equivalent) in 1990 in Austria to that in Brazil?
Offer a very short reply. 0.27. What is the ratio of the SF6 emissions (in thousand metric tons of CO2 equivalent) in 2000 in Austria to that in Brazil?
Give a very brief answer. 0.39. What is the ratio of the SF6 emissions (in thousand metric tons of CO2 equivalent) of 2005 in Austria to that in Brazil?
Ensure brevity in your answer.  0.14. What is the ratio of the SF6 emissions (in thousand metric tons of CO2 equivalent) in 2008 in Austria to that in Brazil?
Give a very brief answer. 0.14. What is the ratio of the SF6 emissions (in thousand metric tons of CO2 equivalent) of 1990 in Austria to that in Canada?
Offer a terse response. 0.1. What is the ratio of the SF6 emissions (in thousand metric tons of CO2 equivalent) in 2000 in Austria to that in Canada?
Give a very brief answer. 0.06. What is the ratio of the SF6 emissions (in thousand metric tons of CO2 equivalent) in 2005 in Austria to that in Canada?
Keep it short and to the point. 0.04. What is the ratio of the SF6 emissions (in thousand metric tons of CO2 equivalent) of 2008 in Austria to that in Canada?
Offer a very short reply. 0.05. What is the ratio of the SF6 emissions (in thousand metric tons of CO2 equivalent) in 1990 in Austria to that in Chile?
Your response must be concise. 24.92. What is the ratio of the SF6 emissions (in thousand metric tons of CO2 equivalent) of 2000 in Austria to that in Chile?
Provide a short and direct response. 43.94. What is the ratio of the SF6 emissions (in thousand metric tons of CO2 equivalent) in 2005 in Austria to that in Chile?
Provide a succinct answer. 18.78. What is the ratio of the SF6 emissions (in thousand metric tons of CO2 equivalent) of 2008 in Austria to that in Chile?
Keep it short and to the point. 24.86. What is the ratio of the SF6 emissions (in thousand metric tons of CO2 equivalent) in 1990 in Belgium to that in Brazil?
Provide a short and direct response. 0.09. What is the ratio of the SF6 emissions (in thousand metric tons of CO2 equivalent) of 2000 in Belgium to that in Brazil?
Your response must be concise. 0.17. What is the ratio of the SF6 emissions (in thousand metric tons of CO2 equivalent) in 2005 in Belgium to that in Brazil?
Your answer should be compact. 0.06. What is the ratio of the SF6 emissions (in thousand metric tons of CO2 equivalent) in 2008 in Belgium to that in Brazil?
Provide a short and direct response. 0.06. What is the ratio of the SF6 emissions (in thousand metric tons of CO2 equivalent) in 1990 in Belgium to that in Canada?
Provide a succinct answer. 0.03. What is the ratio of the SF6 emissions (in thousand metric tons of CO2 equivalent) of 2000 in Belgium to that in Canada?
Your response must be concise. 0.03. What is the ratio of the SF6 emissions (in thousand metric tons of CO2 equivalent) of 2005 in Belgium to that in Canada?
Offer a very short reply. 0.02. What is the ratio of the SF6 emissions (in thousand metric tons of CO2 equivalent) of 2008 in Belgium to that in Canada?
Provide a short and direct response. 0.02. What is the ratio of the SF6 emissions (in thousand metric tons of CO2 equivalent) in 1990 in Belgium to that in Chile?
Your answer should be compact. 8.39. What is the ratio of the SF6 emissions (in thousand metric tons of CO2 equivalent) in 2000 in Belgium to that in Chile?
Provide a short and direct response. 19.66. What is the ratio of the SF6 emissions (in thousand metric tons of CO2 equivalent) in 2005 in Belgium to that in Chile?
Provide a short and direct response. 8.1. What is the ratio of the SF6 emissions (in thousand metric tons of CO2 equivalent) of 2008 in Belgium to that in Chile?
Your response must be concise. 10.24. What is the ratio of the SF6 emissions (in thousand metric tons of CO2 equivalent) of 1990 in Brazil to that in Canada?
Your answer should be very brief. 0.38. What is the ratio of the SF6 emissions (in thousand metric tons of CO2 equivalent) in 2000 in Brazil to that in Canada?
Provide a short and direct response. 0.15. What is the ratio of the SF6 emissions (in thousand metric tons of CO2 equivalent) of 2005 in Brazil to that in Canada?
Your answer should be very brief. 0.29. What is the ratio of the SF6 emissions (in thousand metric tons of CO2 equivalent) of 2008 in Brazil to that in Canada?
Keep it short and to the point. 0.33. What is the ratio of the SF6 emissions (in thousand metric tons of CO2 equivalent) in 1990 in Brazil to that in Chile?
Your response must be concise. 91.39. What is the ratio of the SF6 emissions (in thousand metric tons of CO2 equivalent) of 2000 in Brazil to that in Chile?
Provide a short and direct response. 113.24. What is the ratio of the SF6 emissions (in thousand metric tons of CO2 equivalent) in 2005 in Brazil to that in Chile?
Offer a very short reply. 133.56. What is the ratio of the SF6 emissions (in thousand metric tons of CO2 equivalent) of 2008 in Brazil to that in Chile?
Your answer should be very brief. 176.87. What is the ratio of the SF6 emissions (in thousand metric tons of CO2 equivalent) of 1990 in Canada to that in Chile?
Your answer should be compact. 240.72. What is the ratio of the SF6 emissions (in thousand metric tons of CO2 equivalent) of 2000 in Canada to that in Chile?
Your answer should be very brief. 736.58. What is the ratio of the SF6 emissions (in thousand metric tons of CO2 equivalent) in 2005 in Canada to that in Chile?
Keep it short and to the point. 462.64. What is the ratio of the SF6 emissions (in thousand metric tons of CO2 equivalent) of 2008 in Canada to that in Chile?
Your response must be concise. 532.76. What is the difference between the highest and the second highest SF6 emissions (in thousand metric tons of CO2 equivalent) in 1990?
Make the answer very short. 2463.9. What is the difference between the highest and the second highest SF6 emissions (in thousand metric tons of CO2 equivalent) of 2000?
Ensure brevity in your answer.  4176.4. What is the difference between the highest and the second highest SF6 emissions (in thousand metric tons of CO2 equivalent) in 2005?
Provide a succinct answer. 2961.8. What is the difference between the highest and the second highest SF6 emissions (in thousand metric tons of CO2 equivalent) of 2008?
Your response must be concise. 2811.5. What is the difference between the highest and the lowest SF6 emissions (in thousand metric tons of CO2 equivalent) in 1990?
Ensure brevity in your answer.  3955.3. What is the difference between the highest and the lowest SF6 emissions (in thousand metric tons of CO2 equivalent) in 2000?
Your response must be concise. 4928.4. What is the difference between the highest and the lowest SF6 emissions (in thousand metric tons of CO2 equivalent) of 2005?
Offer a very short reply. 4154.8. What is the difference between the highest and the lowest SF6 emissions (in thousand metric tons of CO2 equivalent) of 2008?
Make the answer very short. 4200.9. 